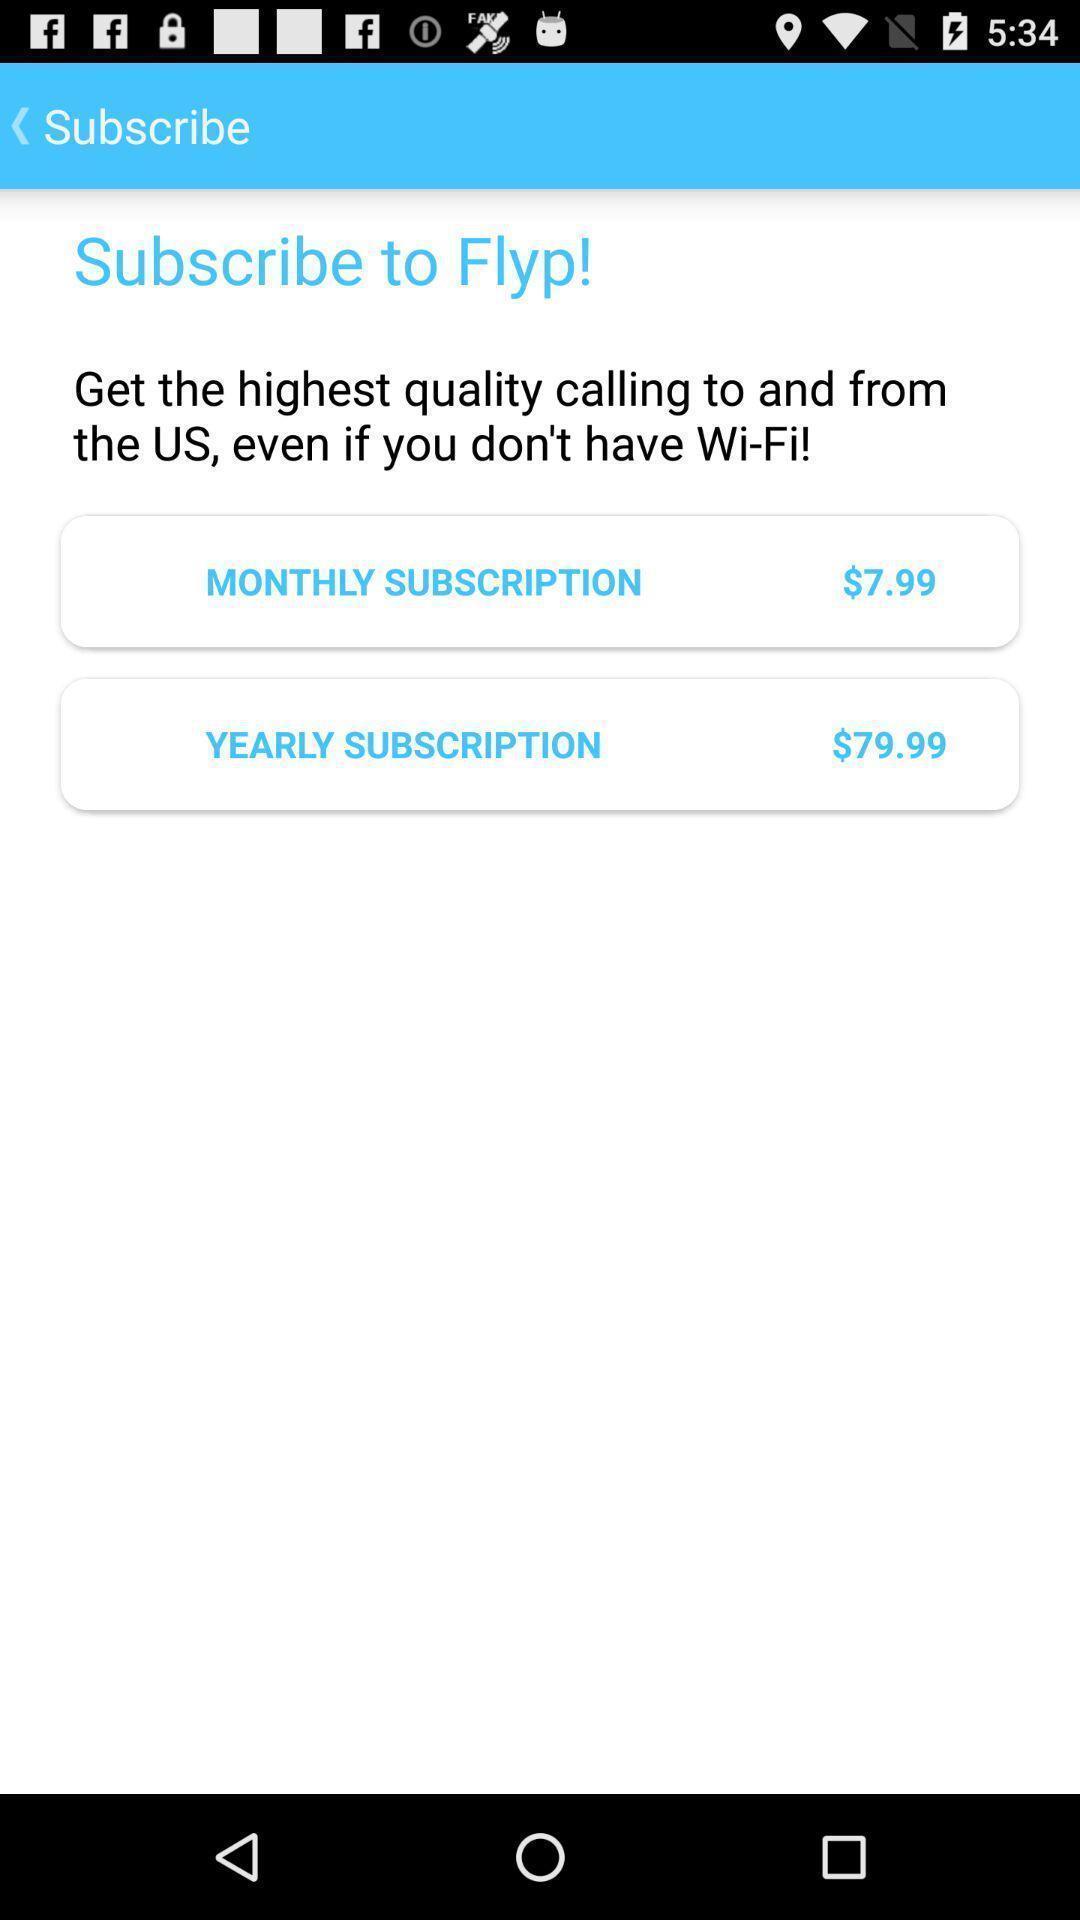Provide a textual representation of this image. Page with subscription plans for a caller app. 